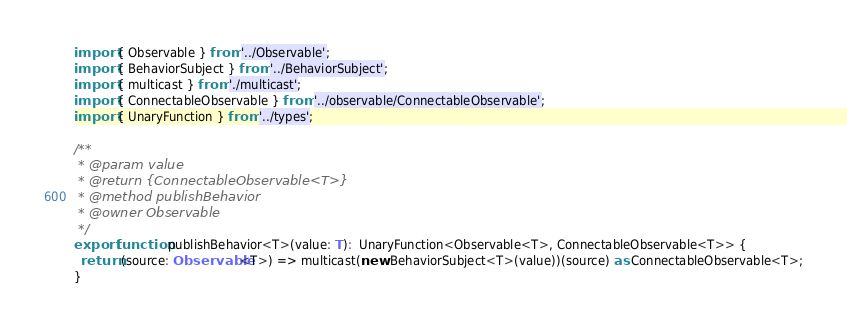Convert code to text. <code><loc_0><loc_0><loc_500><loc_500><_TypeScript_>import { Observable } from '../Observable';
import { BehaviorSubject } from '../BehaviorSubject';
import { multicast } from './multicast';
import { ConnectableObservable } from '../observable/ConnectableObservable';
import { UnaryFunction } from '../types';

/**
 * @param value
 * @return {ConnectableObservable<T>}
 * @method publishBehavior
 * @owner Observable
 */
export function publishBehavior<T>(value: T):  UnaryFunction<Observable<T>, ConnectableObservable<T>> {
  return (source: Observable<T>) => multicast(new BehaviorSubject<T>(value))(source) as ConnectableObservable<T>;
}
</code> 